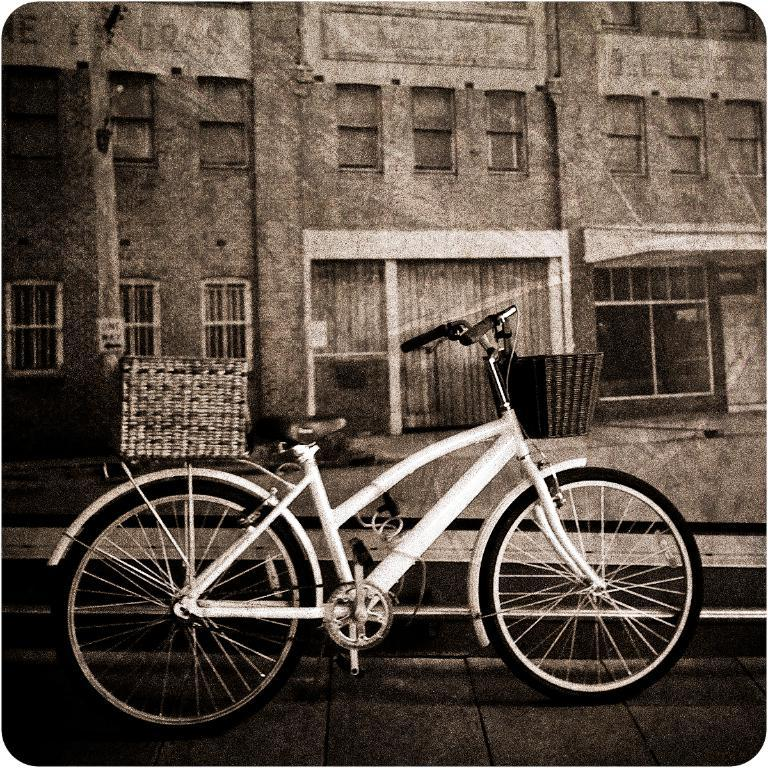What is the main object in the image? There is a bicycle in the image. What additional features does the bicycle have? The bicycle has a basket at the front and a basket at the back. What else can be seen in the image besides the bicycle? There is a building in the image. What can be observed about the building? The building has windows. How many grapes are hanging from the bicycle in the image? There are no grapes present in the image. What is the fifth object in the image? The provided facts do not mention a fifth object in the image. 